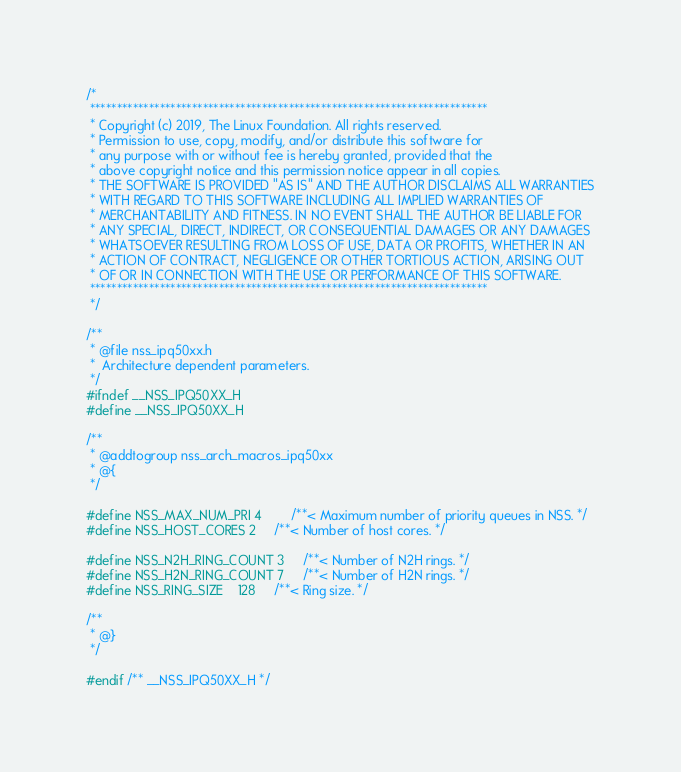<code> <loc_0><loc_0><loc_500><loc_500><_C_>/*
 **************************************************************************
 * Copyright (c) 2019, The Linux Foundation. All rights reserved.
 * Permission to use, copy, modify, and/or distribute this software for
 * any purpose with or without fee is hereby granted, provided that the
 * above copyright notice and this permission notice appear in all copies.
 * THE SOFTWARE IS PROVIDED "AS IS" AND THE AUTHOR DISCLAIMS ALL WARRANTIES
 * WITH REGARD TO THIS SOFTWARE INCLUDING ALL IMPLIED WARRANTIES OF
 * MERCHANTABILITY AND FITNESS. IN NO EVENT SHALL THE AUTHOR BE LIABLE FOR
 * ANY SPECIAL, DIRECT, INDIRECT, OR CONSEQUENTIAL DAMAGES OR ANY DAMAGES
 * WHATSOEVER RESULTING FROM LOSS OF USE, DATA OR PROFITS, WHETHER IN AN
 * ACTION OF CONTRACT, NEGLIGENCE OR OTHER TORTIOUS ACTION, ARISING OUT
 * OF OR IN CONNECTION WITH THE USE OR PERFORMANCE OF THIS SOFTWARE.
 **************************************************************************
 */

/**
 * @file nss_ipq50xx.h
 *	Architecture dependent parameters.
 */
#ifndef __NSS_IPQ50XX_H
#define __NSS_IPQ50XX_H

/**
 * @addtogroup nss_arch_macros_ipq50xx
 * @{
 */

#define NSS_MAX_NUM_PRI 4		/**< Maximum number of priority queues in NSS. */
#define NSS_HOST_CORES 2		/**< Number of host cores. */

#define NSS_N2H_RING_COUNT 3		/**< Number of N2H rings. */
#define NSS_H2N_RING_COUNT 7		/**< Number of H2N rings. */
#define NSS_RING_SIZE	128		/**< Ring size. */

/**
 * @}
 */

#endif /** __NSS_IPQ50XX_H */
</code> 